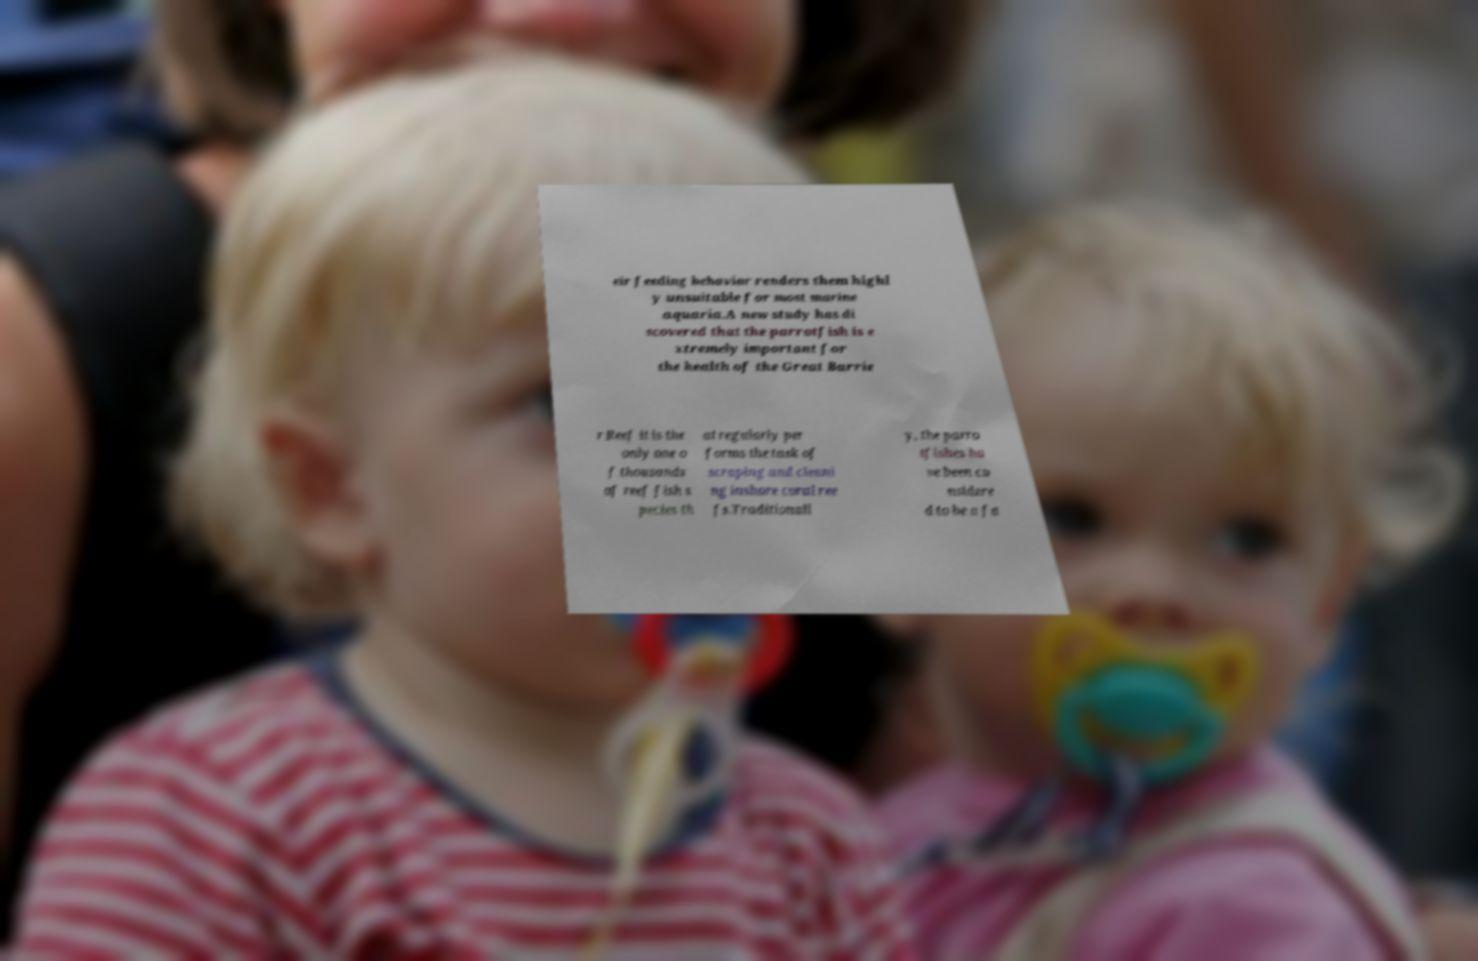Could you assist in decoding the text presented in this image and type it out clearly? eir feeding behavior renders them highl y unsuitable for most marine aquaria.A new study has di scovered that the parrotfish is e xtremely important for the health of the Great Barrie r Reef it is the only one o f thousands of reef fish s pecies th at regularly per forms the task of scraping and cleani ng inshore coral ree fs.Traditionall y, the parro tfishes ha ve been co nsidere d to be a fa 